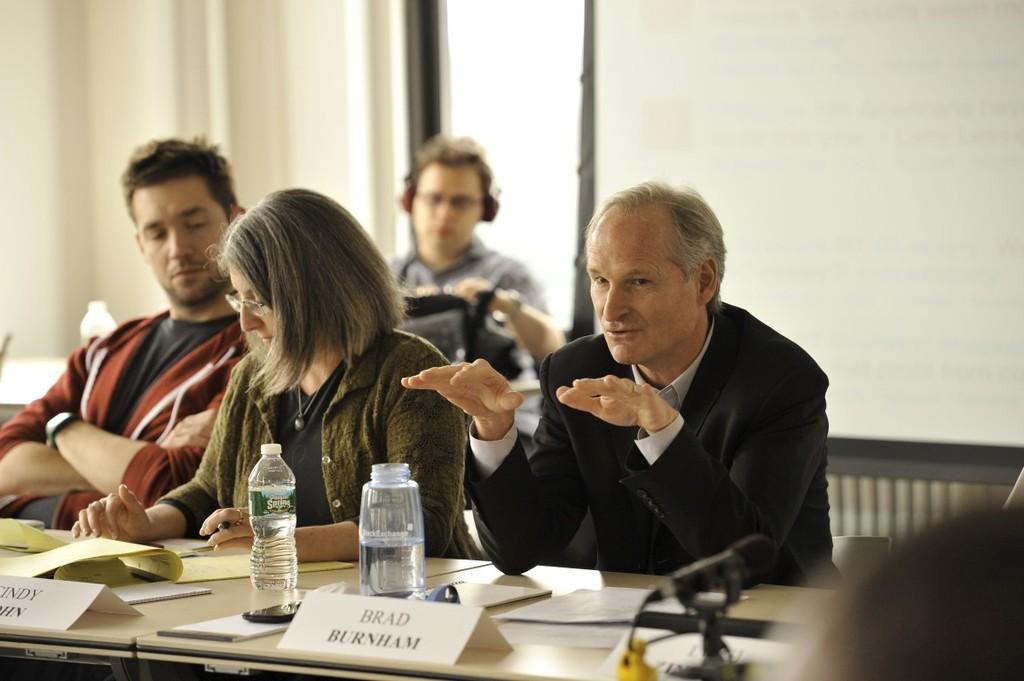What are the people in the image doing? The people in the image are seated on chairs. What objects can be seen on the table in the image? There are bottles, name boards, papers, and microphones on the table in the image. What type of bead is used to create the caption on the microphone in the image? There is no bead or caption present on the microphone in the image. How much shade is provided by the name boards in the image? There is no mention of shade in the image, as it focuses on the people seated on chairs and the objects on the table. 